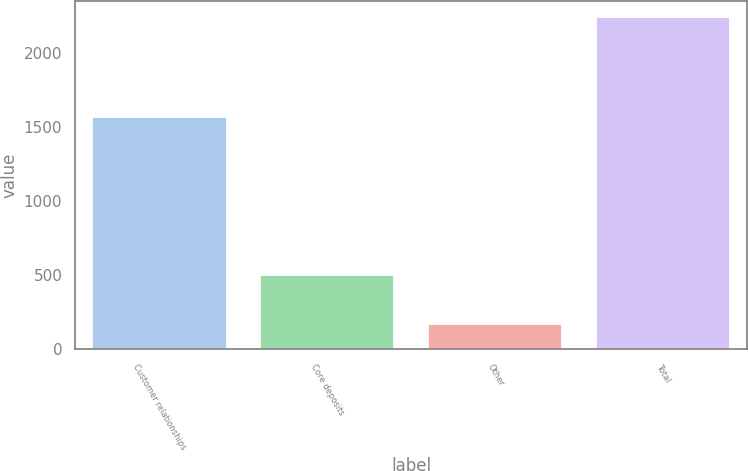Convert chart. <chart><loc_0><loc_0><loc_500><loc_500><bar_chart><fcel>Customer relationships<fcel>Core deposits<fcel>Other<fcel>Total<nl><fcel>1573<fcel>500<fcel>170<fcel>2243<nl></chart> 